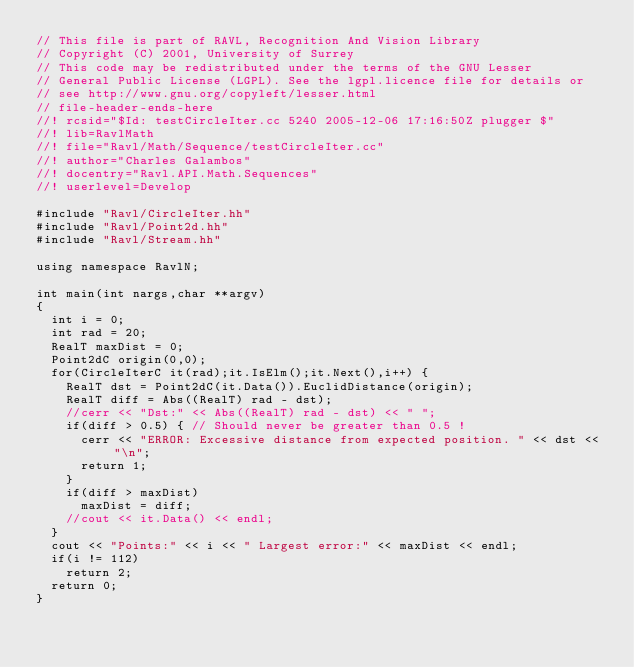Convert code to text. <code><loc_0><loc_0><loc_500><loc_500><_C++_>// This file is part of RAVL, Recognition And Vision Library 
// Copyright (C) 2001, University of Surrey
// This code may be redistributed under the terms of the GNU Lesser
// General Public License (LGPL). See the lgpl.licence file for details or
// see http://www.gnu.org/copyleft/lesser.html
// file-header-ends-here
//! rcsid="$Id: testCircleIter.cc 5240 2005-12-06 17:16:50Z plugger $"
//! lib=RavlMath
//! file="Ravl/Math/Sequence/testCircleIter.cc"
//! author="Charles Galambos"
//! docentry="Ravl.API.Math.Sequences"
//! userlevel=Develop

#include "Ravl/CircleIter.hh"
#include "Ravl/Point2d.hh"
#include "Ravl/Stream.hh"

using namespace RavlN;

int main(int nargs,char **argv) 
{
  int i = 0;
  int rad = 20;
  RealT maxDist = 0;
  Point2dC origin(0,0);
  for(CircleIterC it(rad);it.IsElm();it.Next(),i++) {
    RealT dst = Point2dC(it.Data()).EuclidDistance(origin);
    RealT diff = Abs((RealT) rad - dst);
    //cerr << "Dst:" << Abs((RealT) rad - dst) << " ";
    if(diff > 0.5) { // Should never be greater than 0.5 !
      cerr << "ERROR: Excessive distance from expected position. " << dst << "\n";
      return 1;
    }
    if(diff > maxDist)
      maxDist = diff;
    //cout << it.Data() << endl;
  }
  cout << "Points:" << i << " Largest error:" << maxDist << endl;
  if(i != 112)
    return 2;
  return 0;
}
</code> 